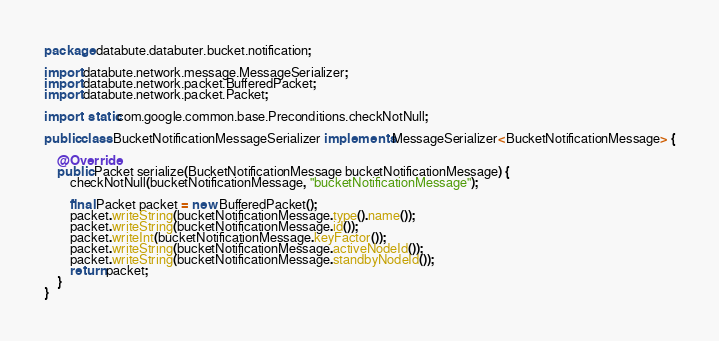<code> <loc_0><loc_0><loc_500><loc_500><_Java_>package databute.databuter.bucket.notification;

import databute.network.message.MessageSerializer;
import databute.network.packet.BufferedPacket;
import databute.network.packet.Packet;

import static com.google.common.base.Preconditions.checkNotNull;

public class BucketNotificationMessageSerializer implements MessageSerializer<BucketNotificationMessage> {

    @Override
    public Packet serialize(BucketNotificationMessage bucketNotificationMessage) {
        checkNotNull(bucketNotificationMessage, "bucketNotificationMessage");

        final Packet packet = new BufferedPacket();
        packet.writeString(bucketNotificationMessage.type().name());
        packet.writeString(bucketNotificationMessage.id());
        packet.writeInt(bucketNotificationMessage.keyFactor());
        packet.writeString(bucketNotificationMessage.activeNodeId());
        packet.writeString(bucketNotificationMessage.standbyNodeId());
        return packet;
    }
}
</code> 